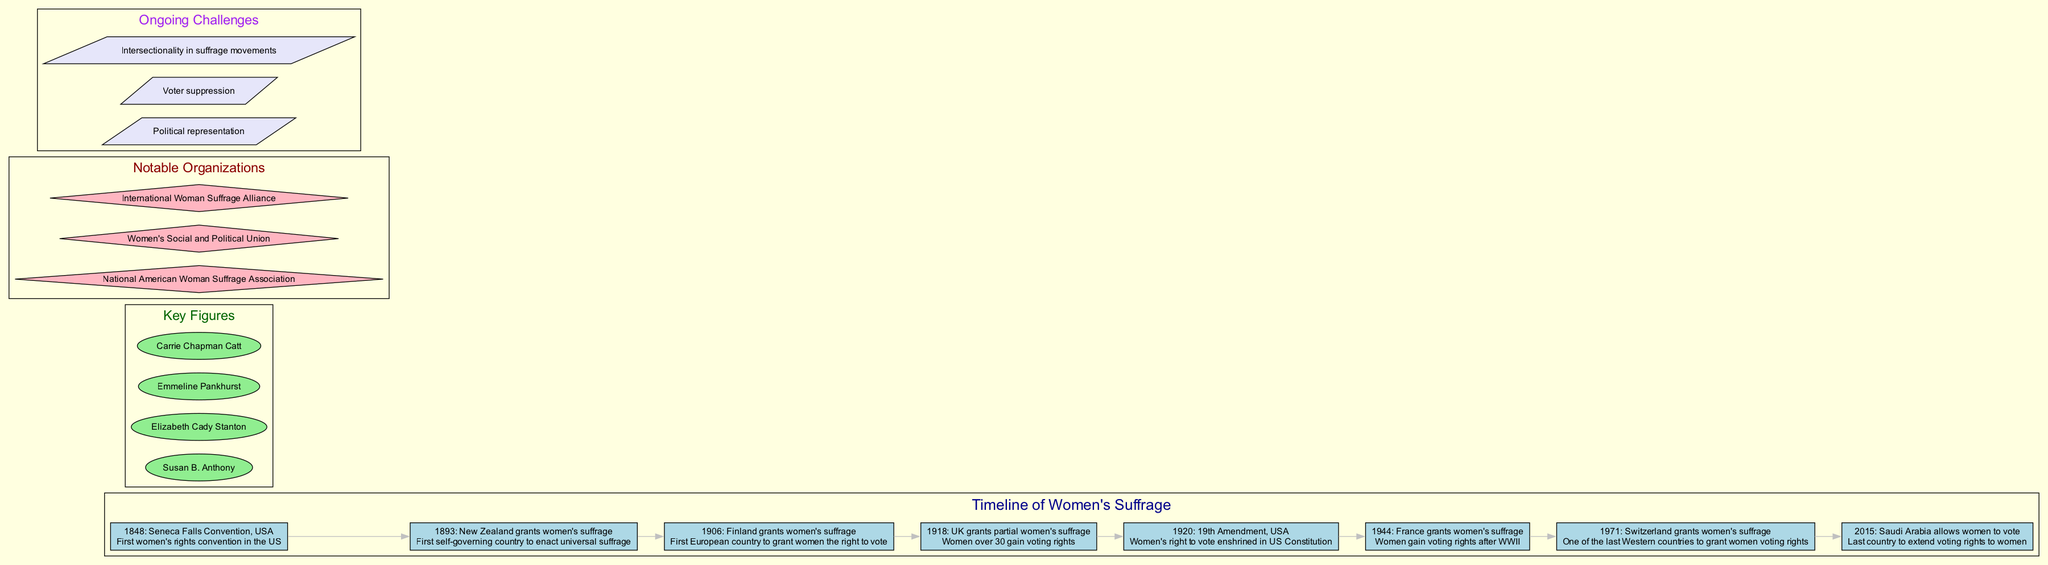What year did New Zealand grant women's suffrage? New Zealand granted women's suffrage in the year 1893, as indicated in the timeline section of the diagram that specifically lists the event along with the year and description.
Answer: 1893 Who was a key figure associated with the women's suffrage movement? The diagram includes a section on key figures and lists several individuals, one of whom is Susan B. Anthony, indicating her significant role in the women's suffrage movement.
Answer: Susan B. Anthony What event marked the first women's rights convention in the US? The diagram notes that the Seneca Falls Convention, which occurred in 1848, was the first women's rights convention in the United States, making it a significant historical event in women's suffrage history.
Answer: Seneca Falls Convention Which country was the first to grant women's suffrage? According to the timeline, New Zealand was the first self-governing country to enact universal suffrage in 1893, making it significant in the history of women's rights.
Answer: New Zealand What year did France grant women's suffrage? The diagram states that France granted women's suffrage in 1944, which can be identified by examining the relevant event listed in the timeline.
Answer: 1944 How many key figures are listed in the diagram? By counting the names in the key figures section of the diagram, we find there are four prominent individuals mentioned, thus answering the question about the total number of listed figures.
Answer: 4 What ongoing challenge is related to representation? The diagram includes a section on ongoing challenges, stating "Political representation" as one of the specific challenges faced in the fight for women's suffrage.
Answer: Political representation In what year did the USA enshrine women's right to vote in the Constitution? The diagram shows that the USA enshrined women's right to vote through the 19th Amendment in the year 1920, which is indicated in the timeline events.
Answer: 1920 What organization is mentioned as notable in the women’s suffrage movement? The diagram highlights the National American Woman Suffrage Association as one among several notable organizations that contributed significantly to the suffrage movement.
Answer: National American Woman Suffrage Association 